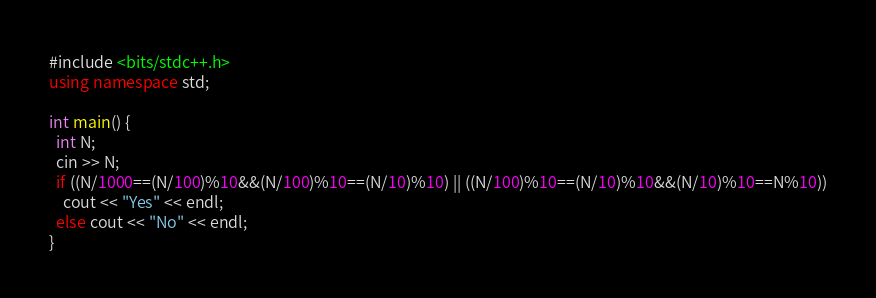Convert code to text. <code><loc_0><loc_0><loc_500><loc_500><_C++_>#include <bits/stdc++.h>
using namespace std;

int main() {
  int N;
  cin >> N;
  if ((N/1000==(N/100)%10&&(N/100)%10==(N/10)%10) || ((N/100)%10==(N/10)%10&&(N/10)%10==N%10))
    cout << "Yes" << endl;
  else cout << "No" << endl;
}</code> 